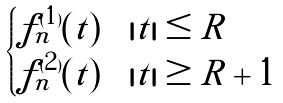<formula> <loc_0><loc_0><loc_500><loc_500>\begin{cases} f _ { n } ^ { ( 1 ) } ( t ) & | t | \leq R \\ f _ { n } ^ { ( 2 ) } ( t ) & | t | \geq R + 1 \end{cases}</formula> 